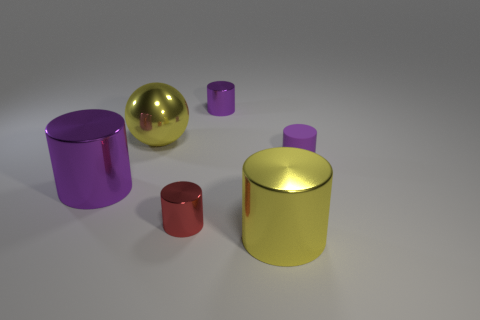Subtract 1 spheres. How many spheres are left? 0 Add 1 big cyan rubber cubes. How many objects exist? 7 Subtract all tiny matte cylinders. How many cylinders are left? 4 Subtract all red cylinders. How many cylinders are left? 4 Subtract all cylinders. How many objects are left? 1 Add 3 small rubber cylinders. How many small rubber cylinders exist? 4 Subtract 0 purple spheres. How many objects are left? 6 Subtract all brown cylinders. Subtract all cyan balls. How many cylinders are left? 5 Subtract all cyan balls. How many yellow cylinders are left? 1 Subtract all small yellow matte cubes. Subtract all matte objects. How many objects are left? 5 